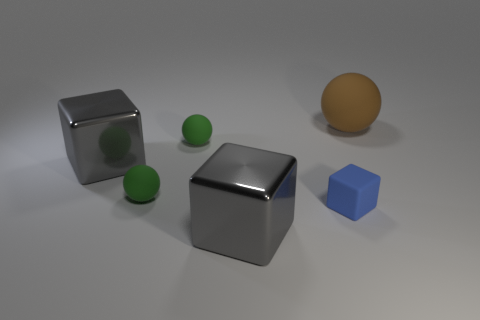Add 4 large gray cubes. How many objects exist? 10 Add 1 tiny blue metallic blocks. How many tiny blue metallic blocks exist? 1 Subtract 0 blue spheres. How many objects are left? 6 Subtract all big rubber spheres. Subtract all cubes. How many objects are left? 2 Add 2 blocks. How many blocks are left? 5 